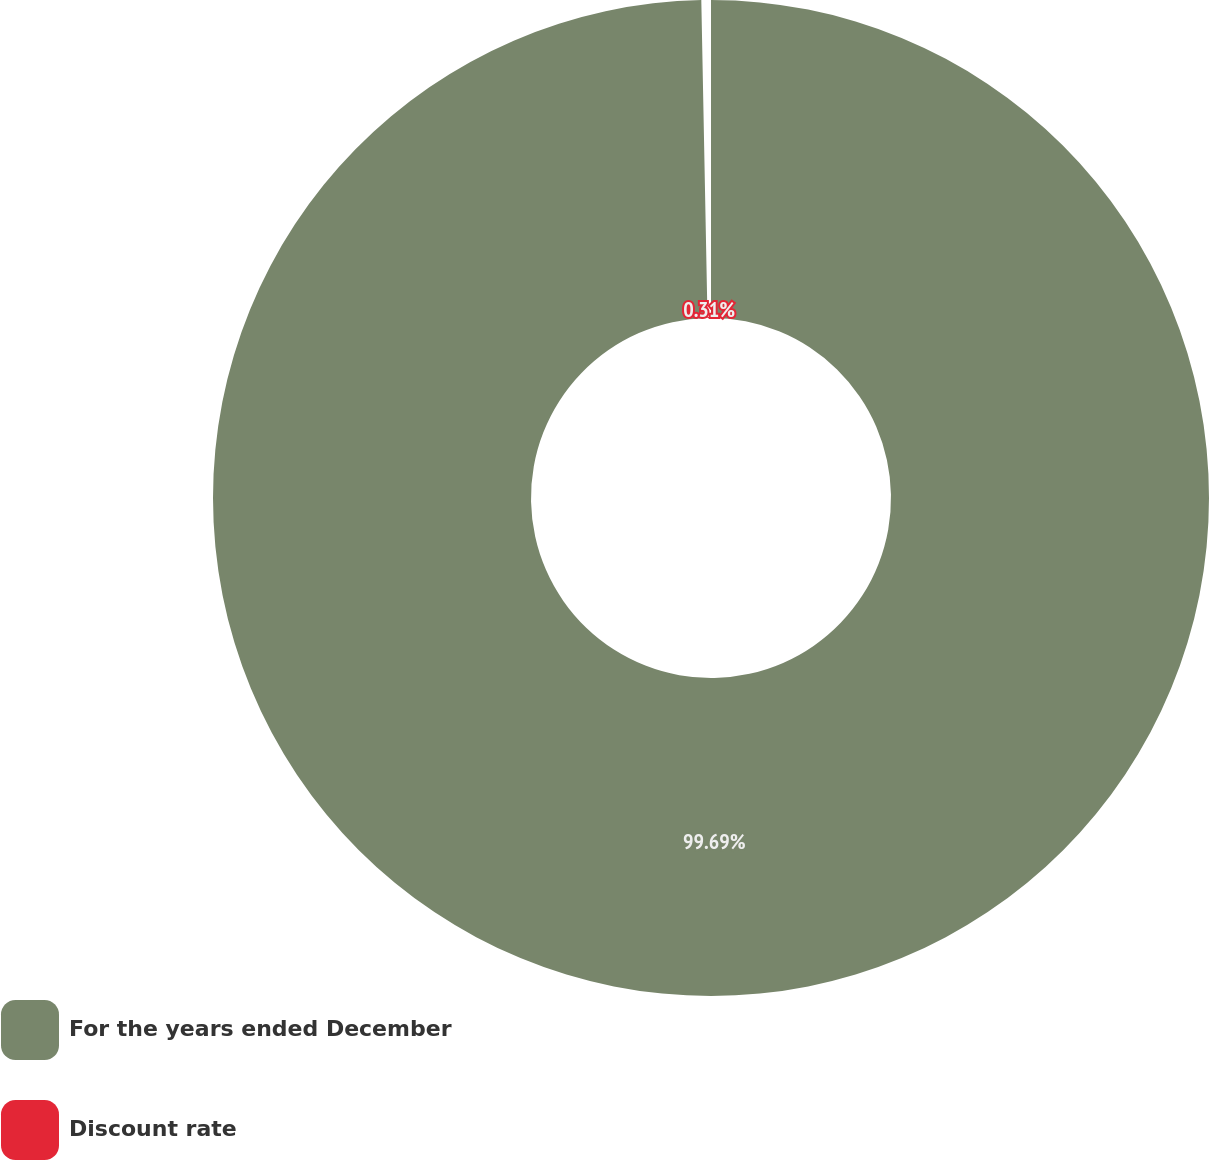Convert chart. <chart><loc_0><loc_0><loc_500><loc_500><pie_chart><fcel>For the years ended December<fcel>Discount rate<nl><fcel>99.69%<fcel>0.31%<nl></chart> 